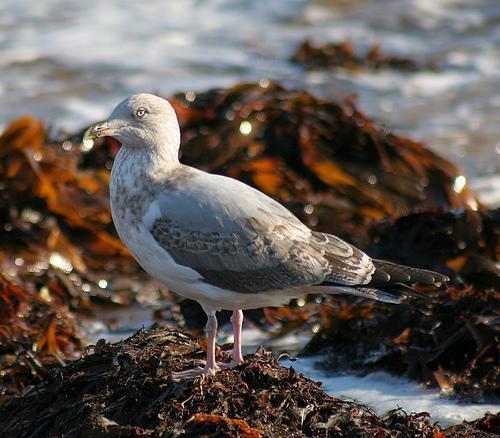How many birds are shown?
Give a very brief answer. 1. 